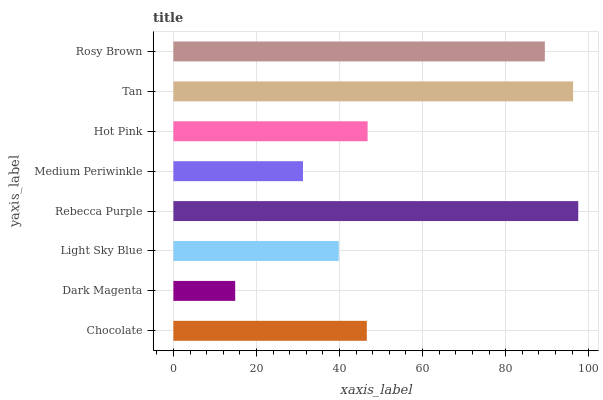Is Dark Magenta the minimum?
Answer yes or no. Yes. Is Rebecca Purple the maximum?
Answer yes or no. Yes. Is Light Sky Blue the minimum?
Answer yes or no. No. Is Light Sky Blue the maximum?
Answer yes or no. No. Is Light Sky Blue greater than Dark Magenta?
Answer yes or no. Yes. Is Dark Magenta less than Light Sky Blue?
Answer yes or no. Yes. Is Dark Magenta greater than Light Sky Blue?
Answer yes or no. No. Is Light Sky Blue less than Dark Magenta?
Answer yes or no. No. Is Hot Pink the high median?
Answer yes or no. Yes. Is Chocolate the low median?
Answer yes or no. Yes. Is Tan the high median?
Answer yes or no. No. Is Rebecca Purple the low median?
Answer yes or no. No. 